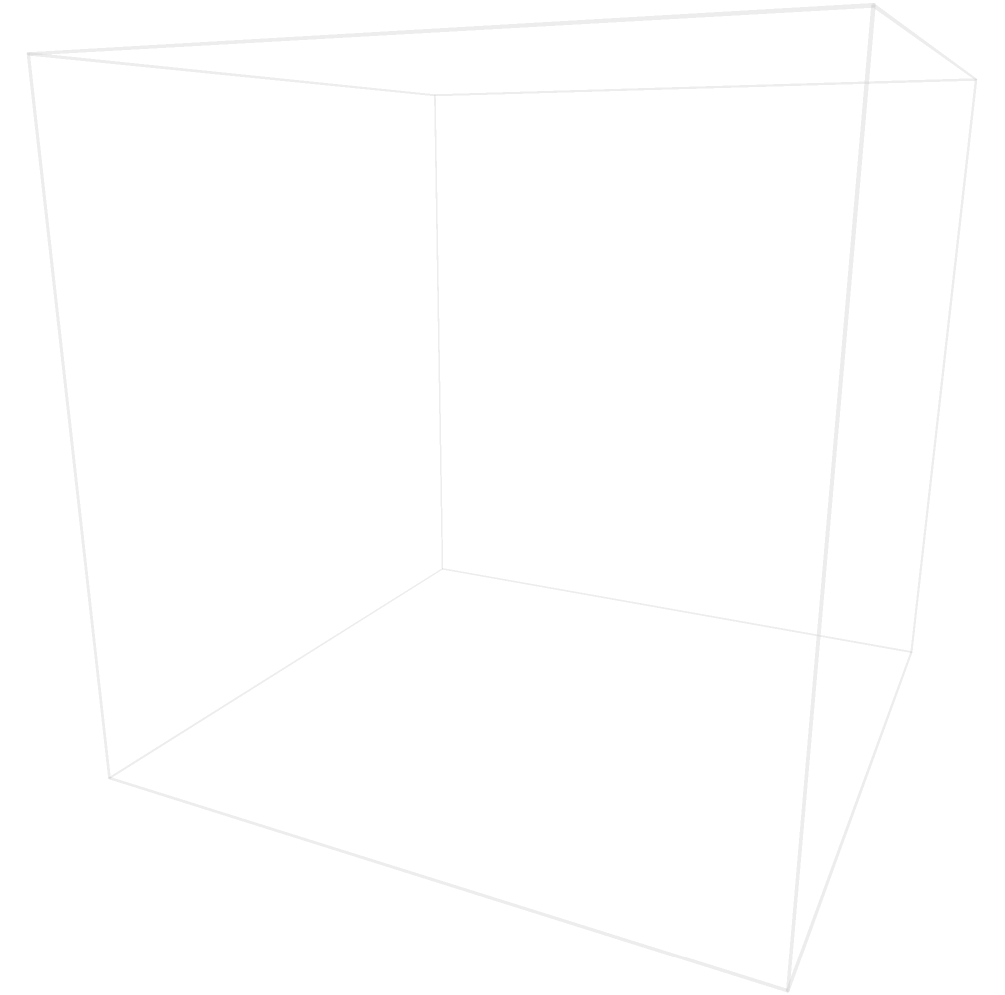In a virtual reality scene, you need to optimize the placement of three spherical objects (A, B, and C) within a cubic space of side length 5 units. Given that sphere A has a radius of 0.8 units, sphere B has a radius of 1.2 units, and sphere C has a radius of 0.6 units, what is the minimum distance between the centers of spheres A and B to ensure they don't intersect while maximizing space efficiency? To solve this problem, we'll follow these steps:

1. Understand the concept: For two spheres to not intersect, the distance between their centers must be greater than or equal to the sum of their radii.

2. Identify the radii:
   Sphere A: $r_A = 0.8$ units
   Sphere B: $r_B = 1.2$ units

3. Calculate the minimum distance:
   Minimum distance = $r_A + r_B$
   $= 0.8 + 1.2$
   $= 2$ units

4. Consider space efficiency:
   To maximize space efficiency, we want to place the spheres as close as possible without intersecting. Therefore, the minimum distance that ensures no intersection is the optimal solution.

5. Verify the solution:
   The calculated distance of 2 units is less than the cube's side length of 5 units, so it's a valid solution within the given space.
Answer: 2 units 